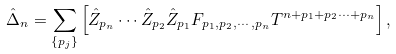<formula> <loc_0><loc_0><loc_500><loc_500>\hat { \Delta } _ { n } = \sum _ { \left \{ p _ { j } \right \} } \left [ \hat { Z } _ { p _ { n } } \cdots \hat { Z } _ { p _ { 2 } } \hat { Z } _ { p _ { 1 } } F _ { p _ { 1 } , p _ { 2 } , \cdots , p _ { n } } T ^ { n + p _ { 1 } + p _ { 2 } \cdots + p _ { n } } \right ] ,</formula> 